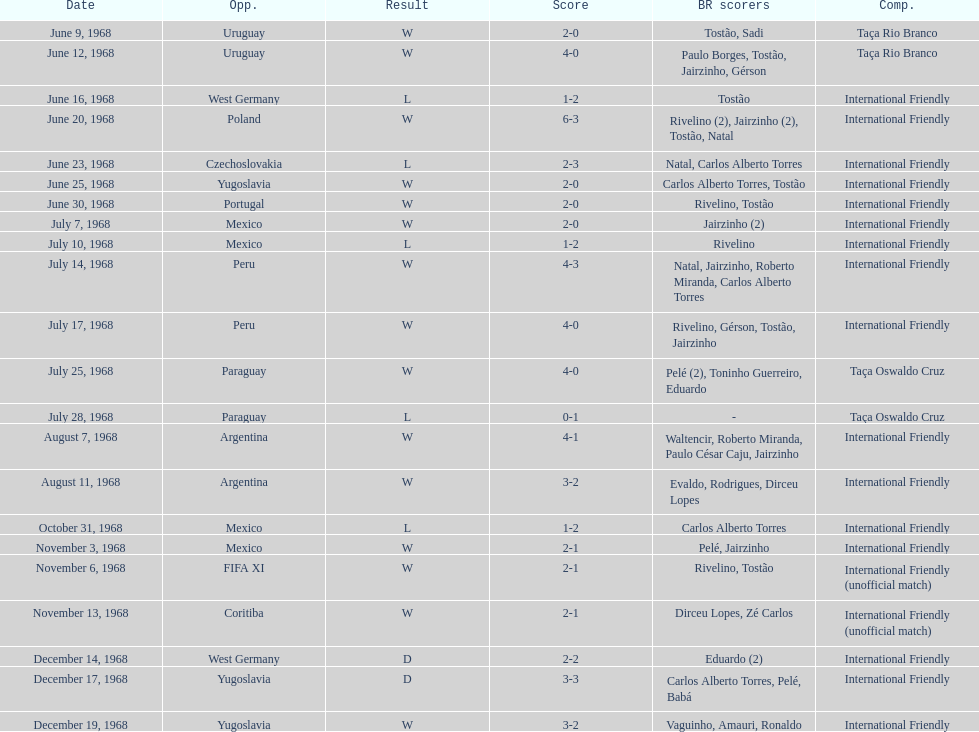The most goals scored by brazil in a game 6. 